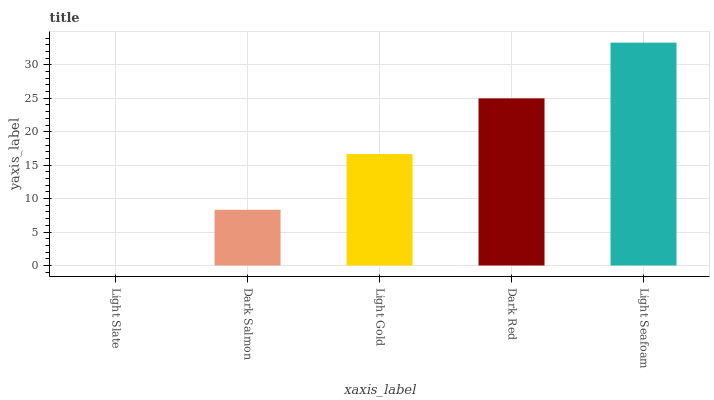Is Light Slate the minimum?
Answer yes or no. Yes. Is Light Seafoam the maximum?
Answer yes or no. Yes. Is Dark Salmon the minimum?
Answer yes or no. No. Is Dark Salmon the maximum?
Answer yes or no. No. Is Dark Salmon greater than Light Slate?
Answer yes or no. Yes. Is Light Slate less than Dark Salmon?
Answer yes or no. Yes. Is Light Slate greater than Dark Salmon?
Answer yes or no. No. Is Dark Salmon less than Light Slate?
Answer yes or no. No. Is Light Gold the high median?
Answer yes or no. Yes. Is Light Gold the low median?
Answer yes or no. Yes. Is Dark Salmon the high median?
Answer yes or no. No. Is Light Slate the low median?
Answer yes or no. No. 